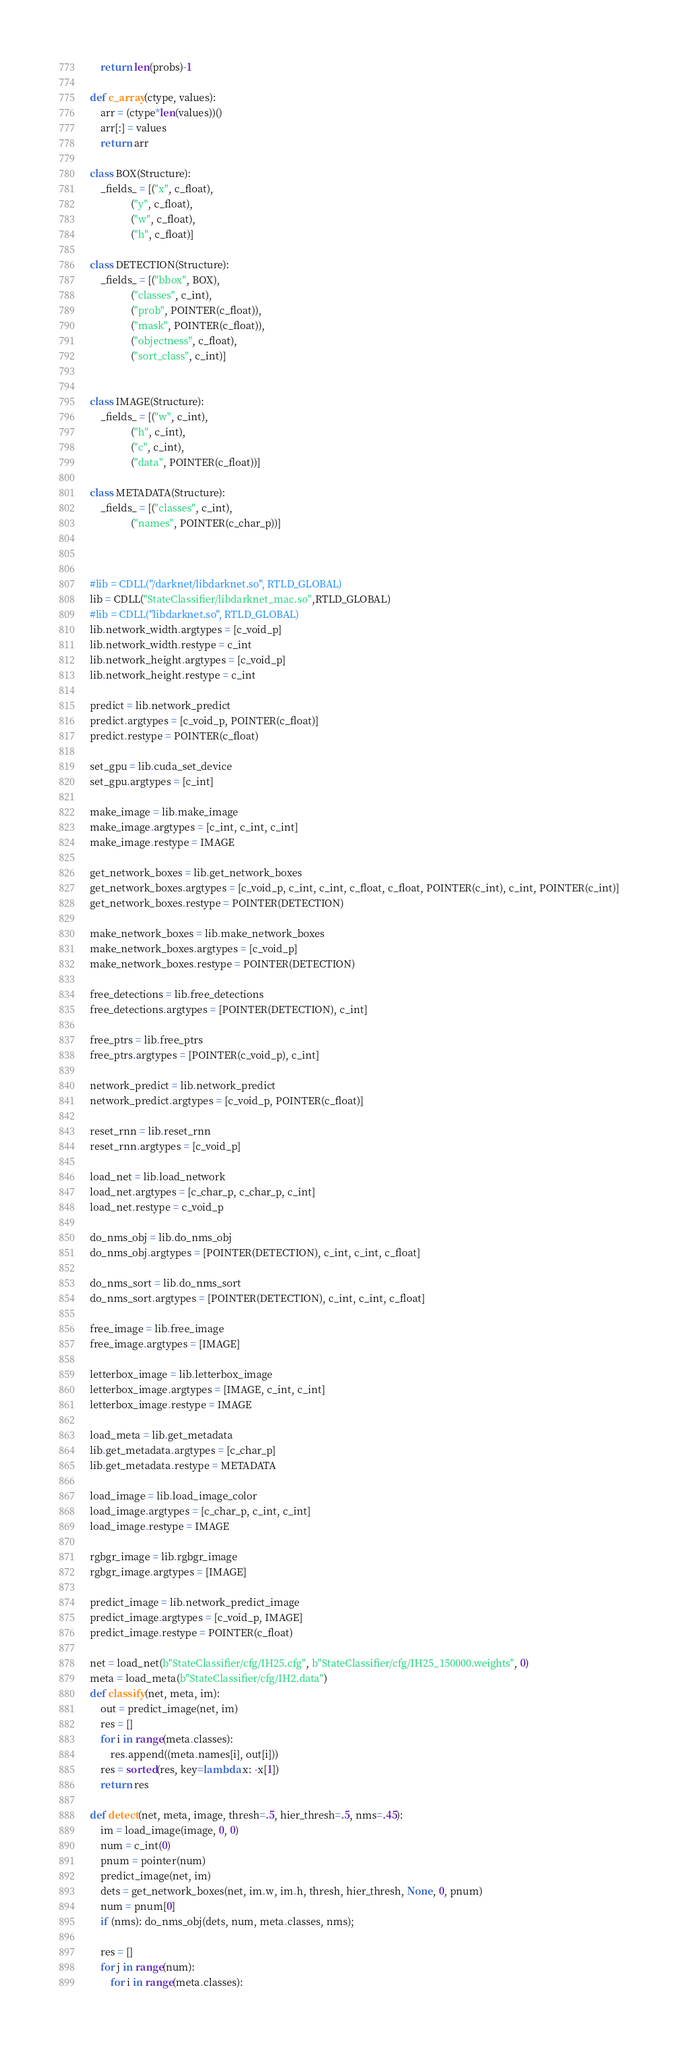Convert code to text. <code><loc_0><loc_0><loc_500><loc_500><_Python_>    return len(probs)-1

def c_array(ctype, values):
    arr = (ctype*len(values))()
    arr[:] = values
    return arr

class BOX(Structure):
    _fields_ = [("x", c_float),
                ("y", c_float),
                ("w", c_float),
                ("h", c_float)]

class DETECTION(Structure):
    _fields_ = [("bbox", BOX),
                ("classes", c_int),
                ("prob", POINTER(c_float)),
                ("mask", POINTER(c_float)),
                ("objectness", c_float),
                ("sort_class", c_int)]


class IMAGE(Structure):
    _fields_ = [("w", c_int),
                ("h", c_int),
                ("c", c_int),
                ("data", POINTER(c_float))]

class METADATA(Structure):
    _fields_ = [("classes", c_int),
                ("names", POINTER(c_char_p))]

    

#lib = CDLL("/darknet/libdarknet.so", RTLD_GLOBAL)
lib = CDLL("StateClassifier/libdarknet_mac.so",RTLD_GLOBAL)
#lib = CDLL("libdarknet.so", RTLD_GLOBAL)
lib.network_width.argtypes = [c_void_p]
lib.network_width.restype = c_int
lib.network_height.argtypes = [c_void_p]
lib.network_height.restype = c_int

predict = lib.network_predict
predict.argtypes = [c_void_p, POINTER(c_float)]
predict.restype = POINTER(c_float)

set_gpu = lib.cuda_set_device
set_gpu.argtypes = [c_int]

make_image = lib.make_image
make_image.argtypes = [c_int, c_int, c_int]
make_image.restype = IMAGE

get_network_boxes = lib.get_network_boxes
get_network_boxes.argtypes = [c_void_p, c_int, c_int, c_float, c_float, POINTER(c_int), c_int, POINTER(c_int)]
get_network_boxes.restype = POINTER(DETECTION)

make_network_boxes = lib.make_network_boxes
make_network_boxes.argtypes = [c_void_p]
make_network_boxes.restype = POINTER(DETECTION)

free_detections = lib.free_detections
free_detections.argtypes = [POINTER(DETECTION), c_int]

free_ptrs = lib.free_ptrs
free_ptrs.argtypes = [POINTER(c_void_p), c_int]

network_predict = lib.network_predict
network_predict.argtypes = [c_void_p, POINTER(c_float)]

reset_rnn = lib.reset_rnn
reset_rnn.argtypes = [c_void_p]

load_net = lib.load_network
load_net.argtypes = [c_char_p, c_char_p, c_int]
load_net.restype = c_void_p

do_nms_obj = lib.do_nms_obj
do_nms_obj.argtypes = [POINTER(DETECTION), c_int, c_int, c_float]

do_nms_sort = lib.do_nms_sort
do_nms_sort.argtypes = [POINTER(DETECTION), c_int, c_int, c_float]

free_image = lib.free_image
free_image.argtypes = [IMAGE]

letterbox_image = lib.letterbox_image
letterbox_image.argtypes = [IMAGE, c_int, c_int]
letterbox_image.restype = IMAGE

load_meta = lib.get_metadata
lib.get_metadata.argtypes = [c_char_p]
lib.get_metadata.restype = METADATA

load_image = lib.load_image_color
load_image.argtypes = [c_char_p, c_int, c_int]
load_image.restype = IMAGE

rgbgr_image = lib.rgbgr_image
rgbgr_image.argtypes = [IMAGE]

predict_image = lib.network_predict_image
predict_image.argtypes = [c_void_p, IMAGE]
predict_image.restype = POINTER(c_float)

net = load_net(b"StateClassifier/cfg/IH25.cfg", b"StateClassifier/cfg/IH25_150000.weights", 0)
meta = load_meta(b"StateClassifier/cfg/IH2.data")
def classify(net, meta, im):
    out = predict_image(net, im)
    res = []
    for i in range(meta.classes):
        res.append((meta.names[i], out[i]))
    res = sorted(res, key=lambda x: -x[1])
    return res

def detect(net, meta, image, thresh=.5, hier_thresh=.5, nms=.45):
    im = load_image(image, 0, 0)
    num = c_int(0)
    pnum = pointer(num)
    predict_image(net, im)
    dets = get_network_boxes(net, im.w, im.h, thresh, hier_thresh, None, 0, pnum)
    num = pnum[0]
    if (nms): do_nms_obj(dets, num, meta.classes, nms);

    res = []
    for j in range(num):
        for i in range(meta.classes):</code> 